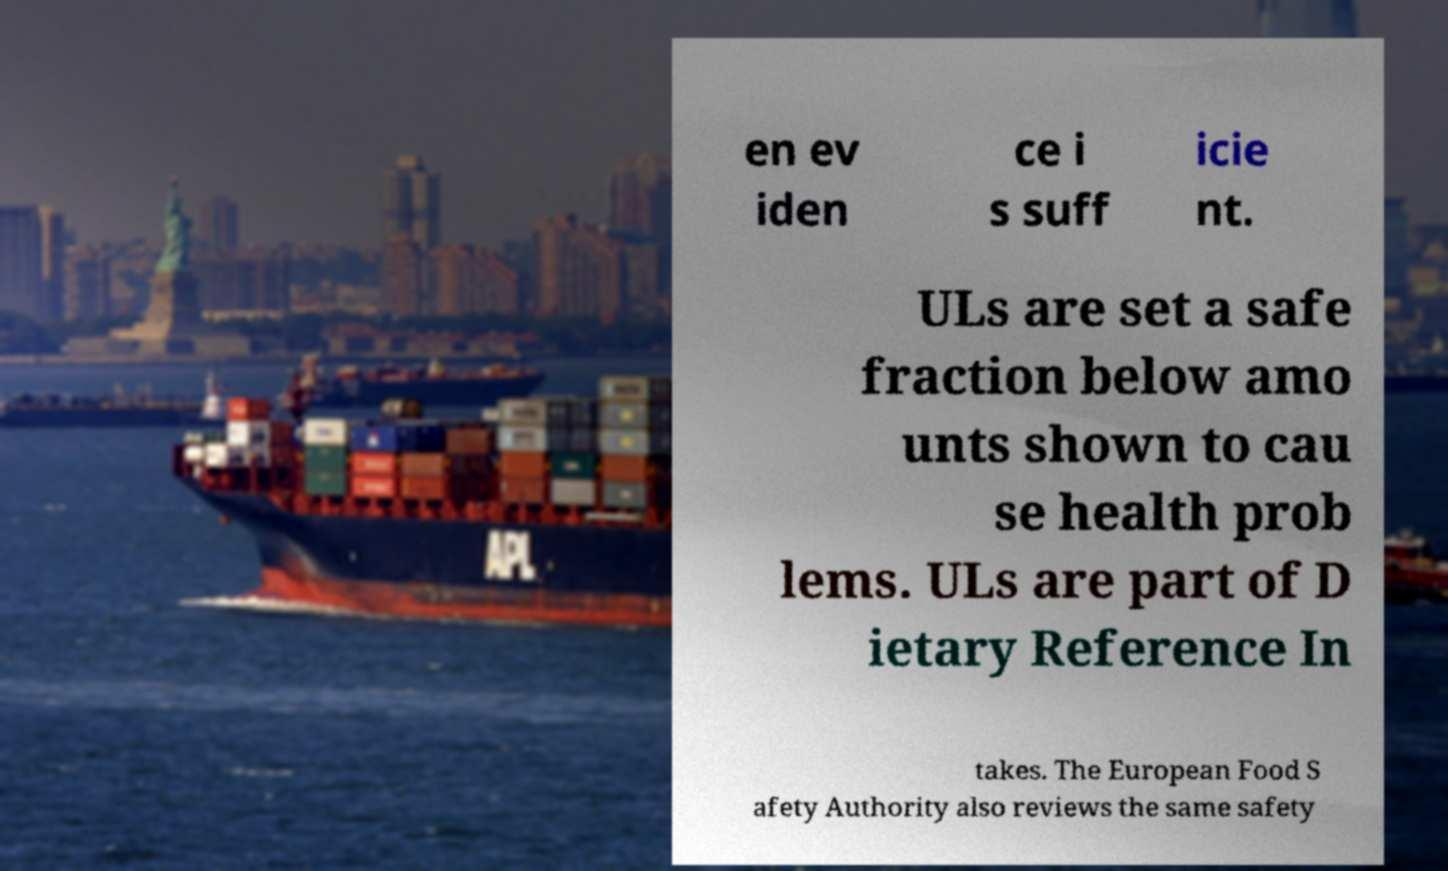There's text embedded in this image that I need extracted. Can you transcribe it verbatim? en ev iden ce i s suff icie nt. ULs are set a safe fraction below amo unts shown to cau se health prob lems. ULs are part of D ietary Reference In takes. The European Food S afety Authority also reviews the same safety 